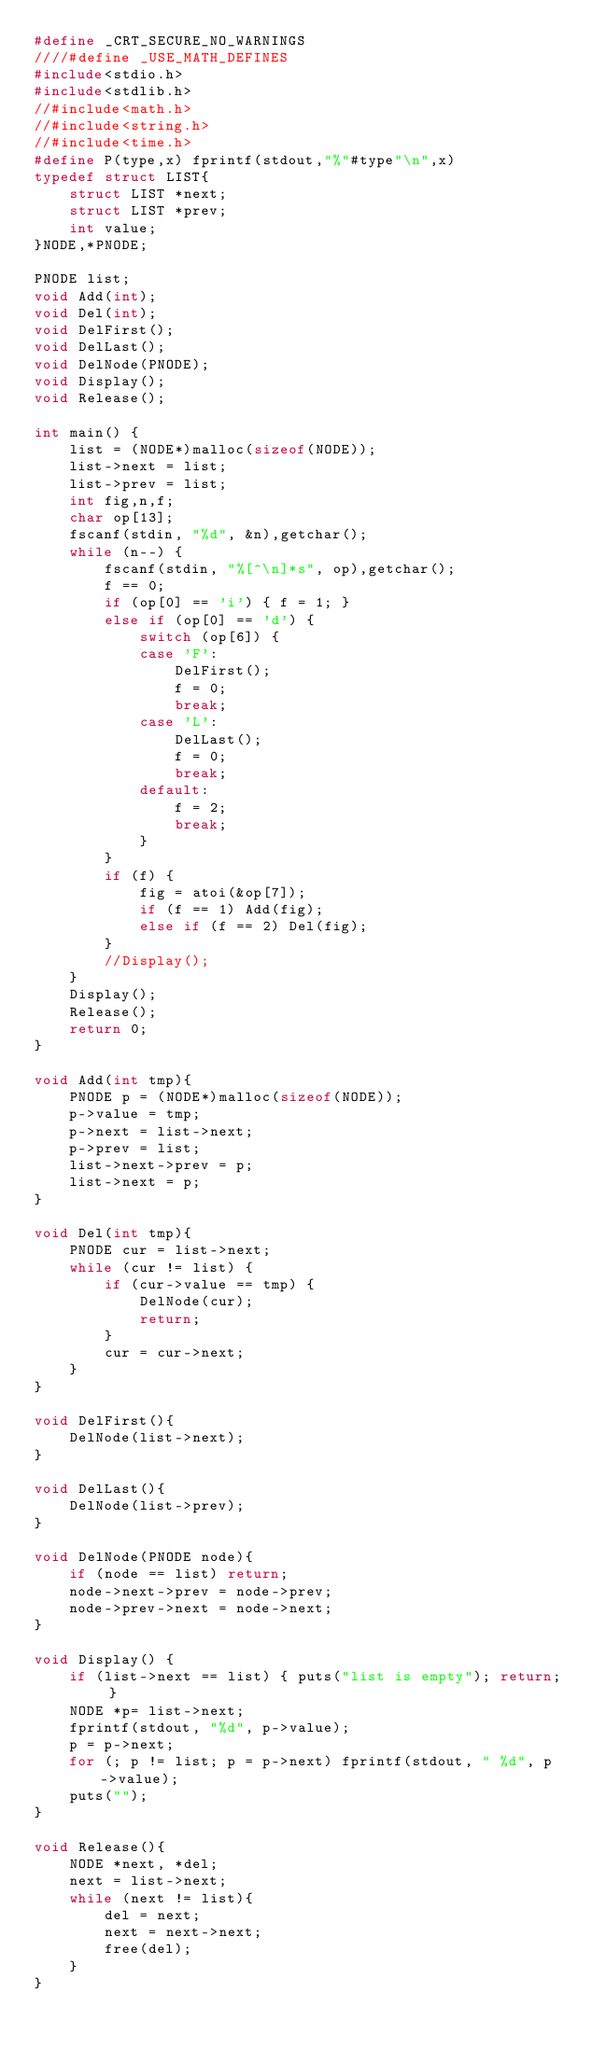Convert code to text. <code><loc_0><loc_0><loc_500><loc_500><_C_>#define _CRT_SECURE_NO_WARNINGS
////#define _USE_MATH_DEFINES
#include<stdio.h>
#include<stdlib.h>
//#include<math.h>
//#include<string.h>
//#include<time.h>
#define P(type,x) fprintf(stdout,"%"#type"\n",x)
typedef struct LIST{
	struct LIST *next;
	struct LIST *prev;
	int value;
}NODE,*PNODE;

PNODE list;
void Add(int);
void Del(int);
void DelFirst();
void DelLast();
void DelNode(PNODE);
void Display();
void Release();

int main() {
	list = (NODE*)malloc(sizeof(NODE));
	list->next = list;
	list->prev = list;
	int fig,n,f;
	char op[13];
	fscanf(stdin, "%d", &n),getchar();
	while (n--) {
		fscanf(stdin, "%[^\n]*s", op),getchar();
		f == 0;
		if (op[0] == 'i') { f = 1; }
		else if (op[0] == 'd') {
			switch (op[6]) {
			case 'F':
				DelFirst();
				f = 0;
				break;
			case 'L':
				DelLast();
				f = 0;
				break;
			default:
				f = 2;
				break;
			}
		}
		if (f) {
			fig = atoi(&op[7]);
			if (f == 1) Add(fig);
			else if (f == 2) Del(fig);
		}
		//Display();
	}
	Display();
	Release();
	return 0;
}

void Add(int tmp){
	PNODE p = (NODE*)malloc(sizeof(NODE));
	p->value = tmp;
	p->next = list->next;
	p->prev = list;
	list->next->prev = p;
	list->next = p;
}

void Del(int tmp){
	PNODE cur = list->next;
	while (cur != list) {
		if (cur->value == tmp) {
			DelNode(cur);
			return;
		}
		cur = cur->next;
	}
}

void DelFirst(){
	DelNode(list->next);
}

void DelLast(){
	DelNode(list->prev);
}

void DelNode(PNODE node){
	if (node == list) return;
	node->next->prev = node->prev;
	node->prev->next = node->next;
}

void Display() {
	if (list->next == list) { puts("list is empty"); return; }
	NODE *p= list->next;
	fprintf(stdout, "%d", p->value);
	p = p->next;
	for (; p != list; p = p->next) fprintf(stdout, " %d", p->value);
	puts("");
}

void Release(){
	NODE *next, *del;
	next = list->next;
	while (next != list){
		del = next;
		next = next->next;
		free(del);
	}
}</code> 